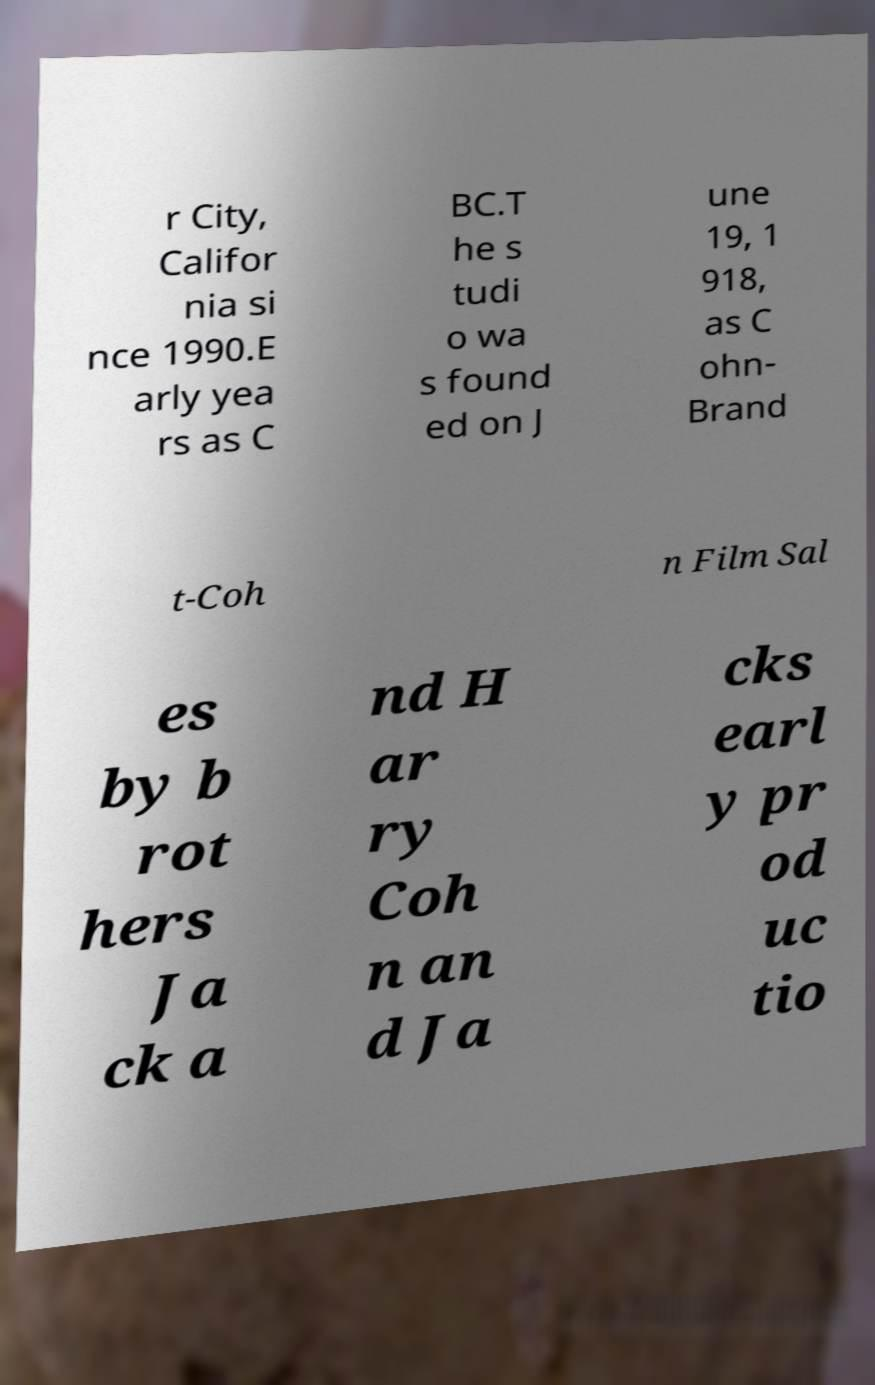Can you read and provide the text displayed in the image?This photo seems to have some interesting text. Can you extract and type it out for me? r City, Califor nia si nce 1990.E arly yea rs as C BC.T he s tudi o wa s found ed on J une 19, 1 918, as C ohn- Brand t-Coh n Film Sal es by b rot hers Ja ck a nd H ar ry Coh n an d Ja cks earl y pr od uc tio 